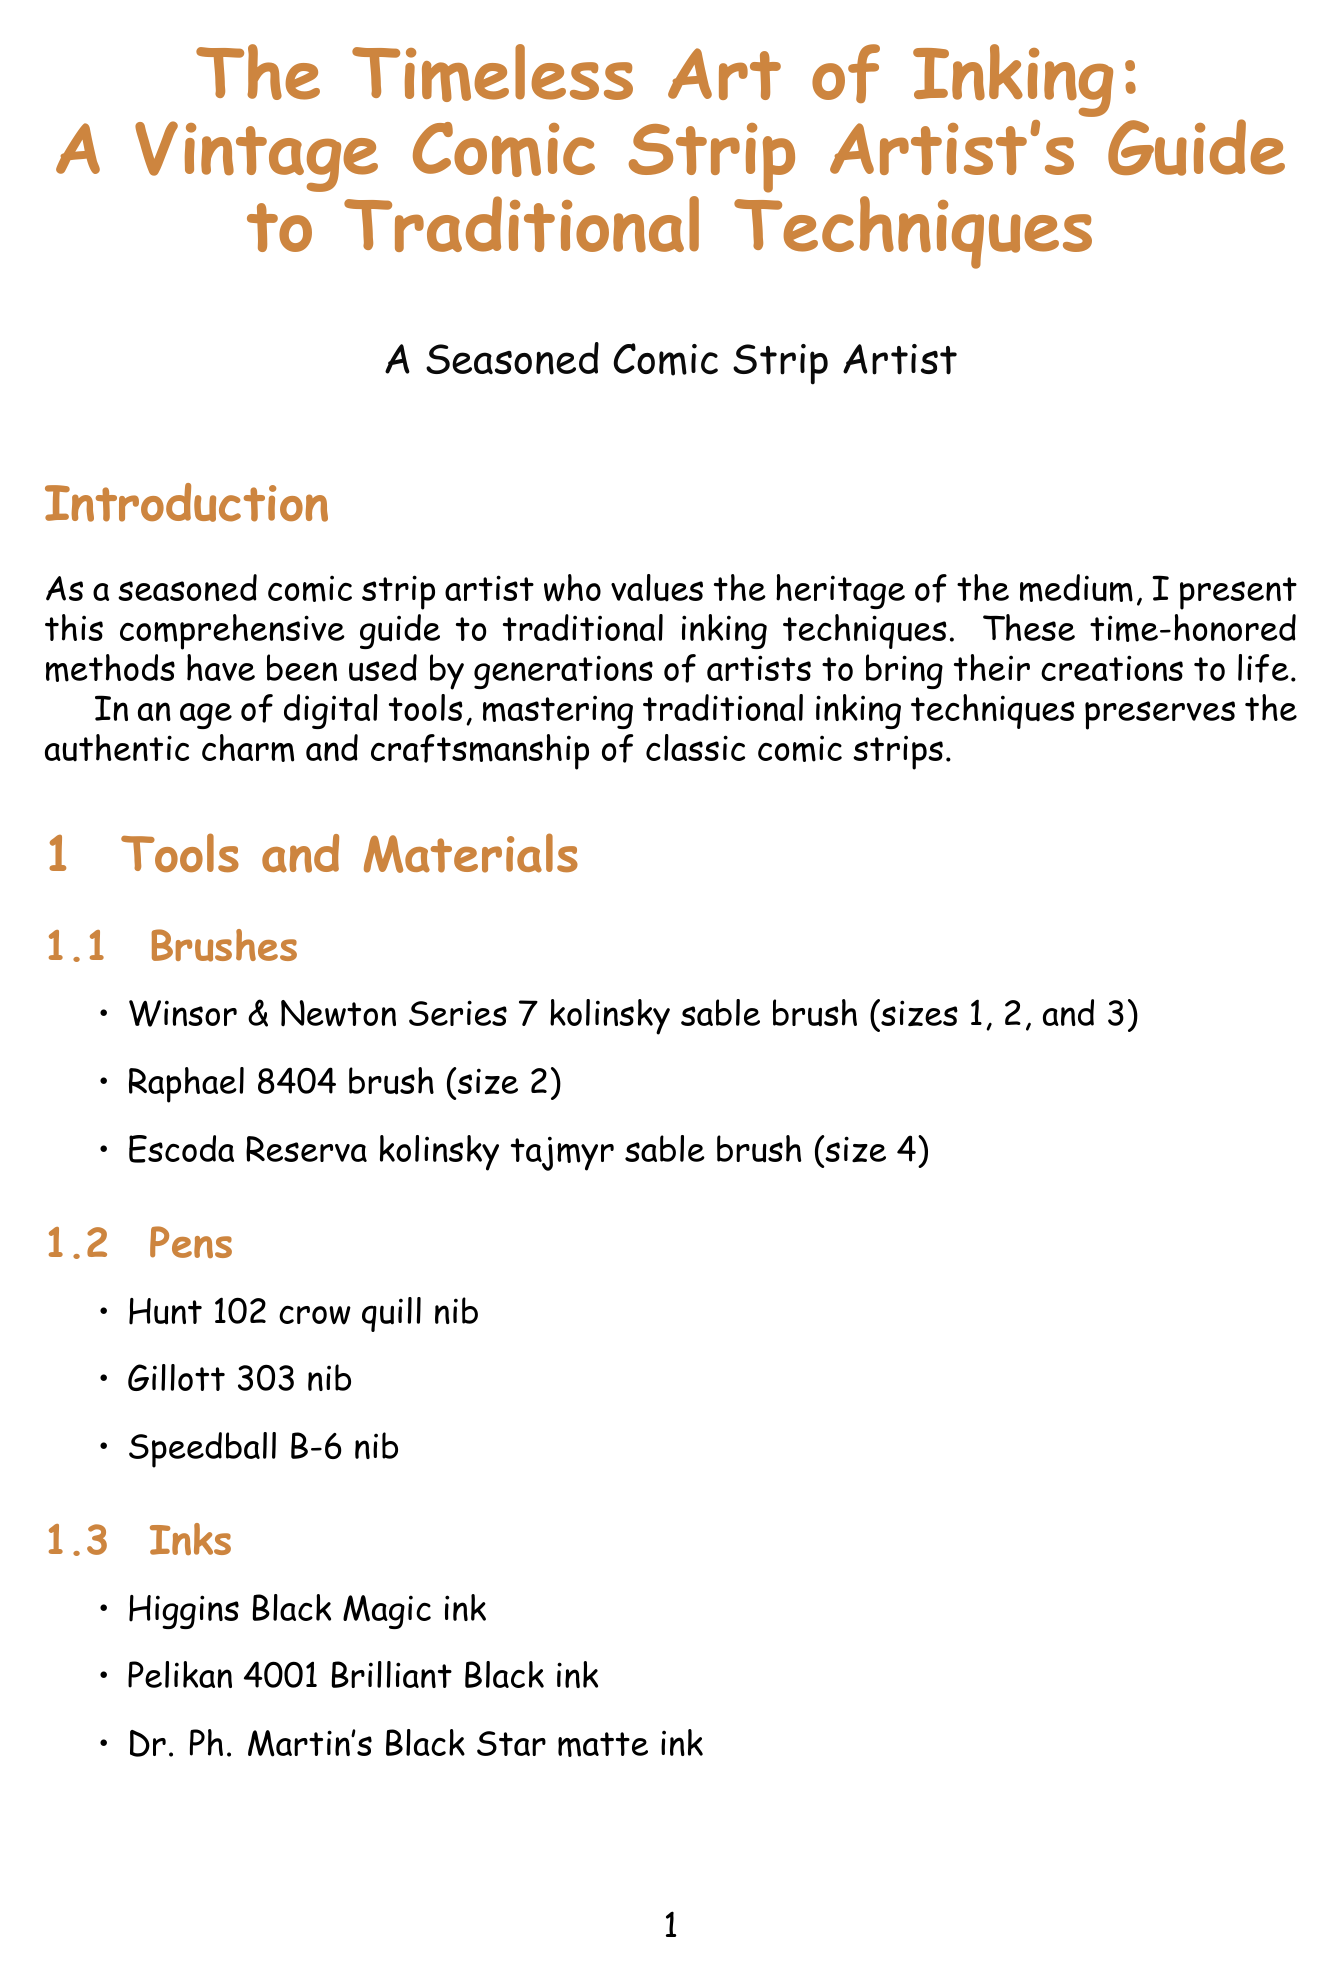What is the title of the document? The title is presented prominently at the beginning of the document and specifies the focus on traditional inking techniques for comic strips.
Answer: The Timeless Art of Inking: A Vintage Comic Strip Artist's Guide to Traditional Techniques Which brush is mentioned as size 4? The specific brush sizes are listed under the tools section, detailing their properties.
Answer: Escoda Reserva kolinsky tajmyr sable brush What technique involves using dots for shading? The document defines this technique along with its historical context and tips for its application.
Answer: Stippling Who mastered the dry brush technique? The document attributes this technique to a specific comic strip artist known for their iconic work.
Answer: Milton Caniff What is recommended to prevent ink bleeding? The troubleshooting section provides solutions for common problems encountered in inking.
Answer: Higher quality paper What is the primary purpose of the ink preservation section? The section discusses methods for handling and preserving artwork to ensure its longevity.
Answer: To prevent fading How many layers are suggested for layered inking? The layered inking technique describes the process of building up ink applications in steps.
Answer: Multiple layers Which two artists are referenced in combined techniques? This information can be cross-referenced from the individual techniques and their associated artists described in the document.
Answer: Alex Raymond and Winsor McCay 